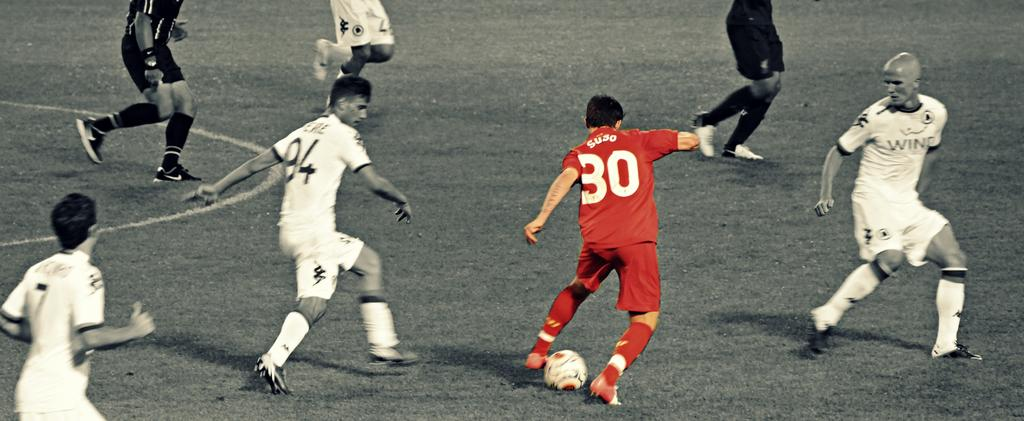<image>
Summarize the visual content of the image. number 30 of the red team is controlling the ball 